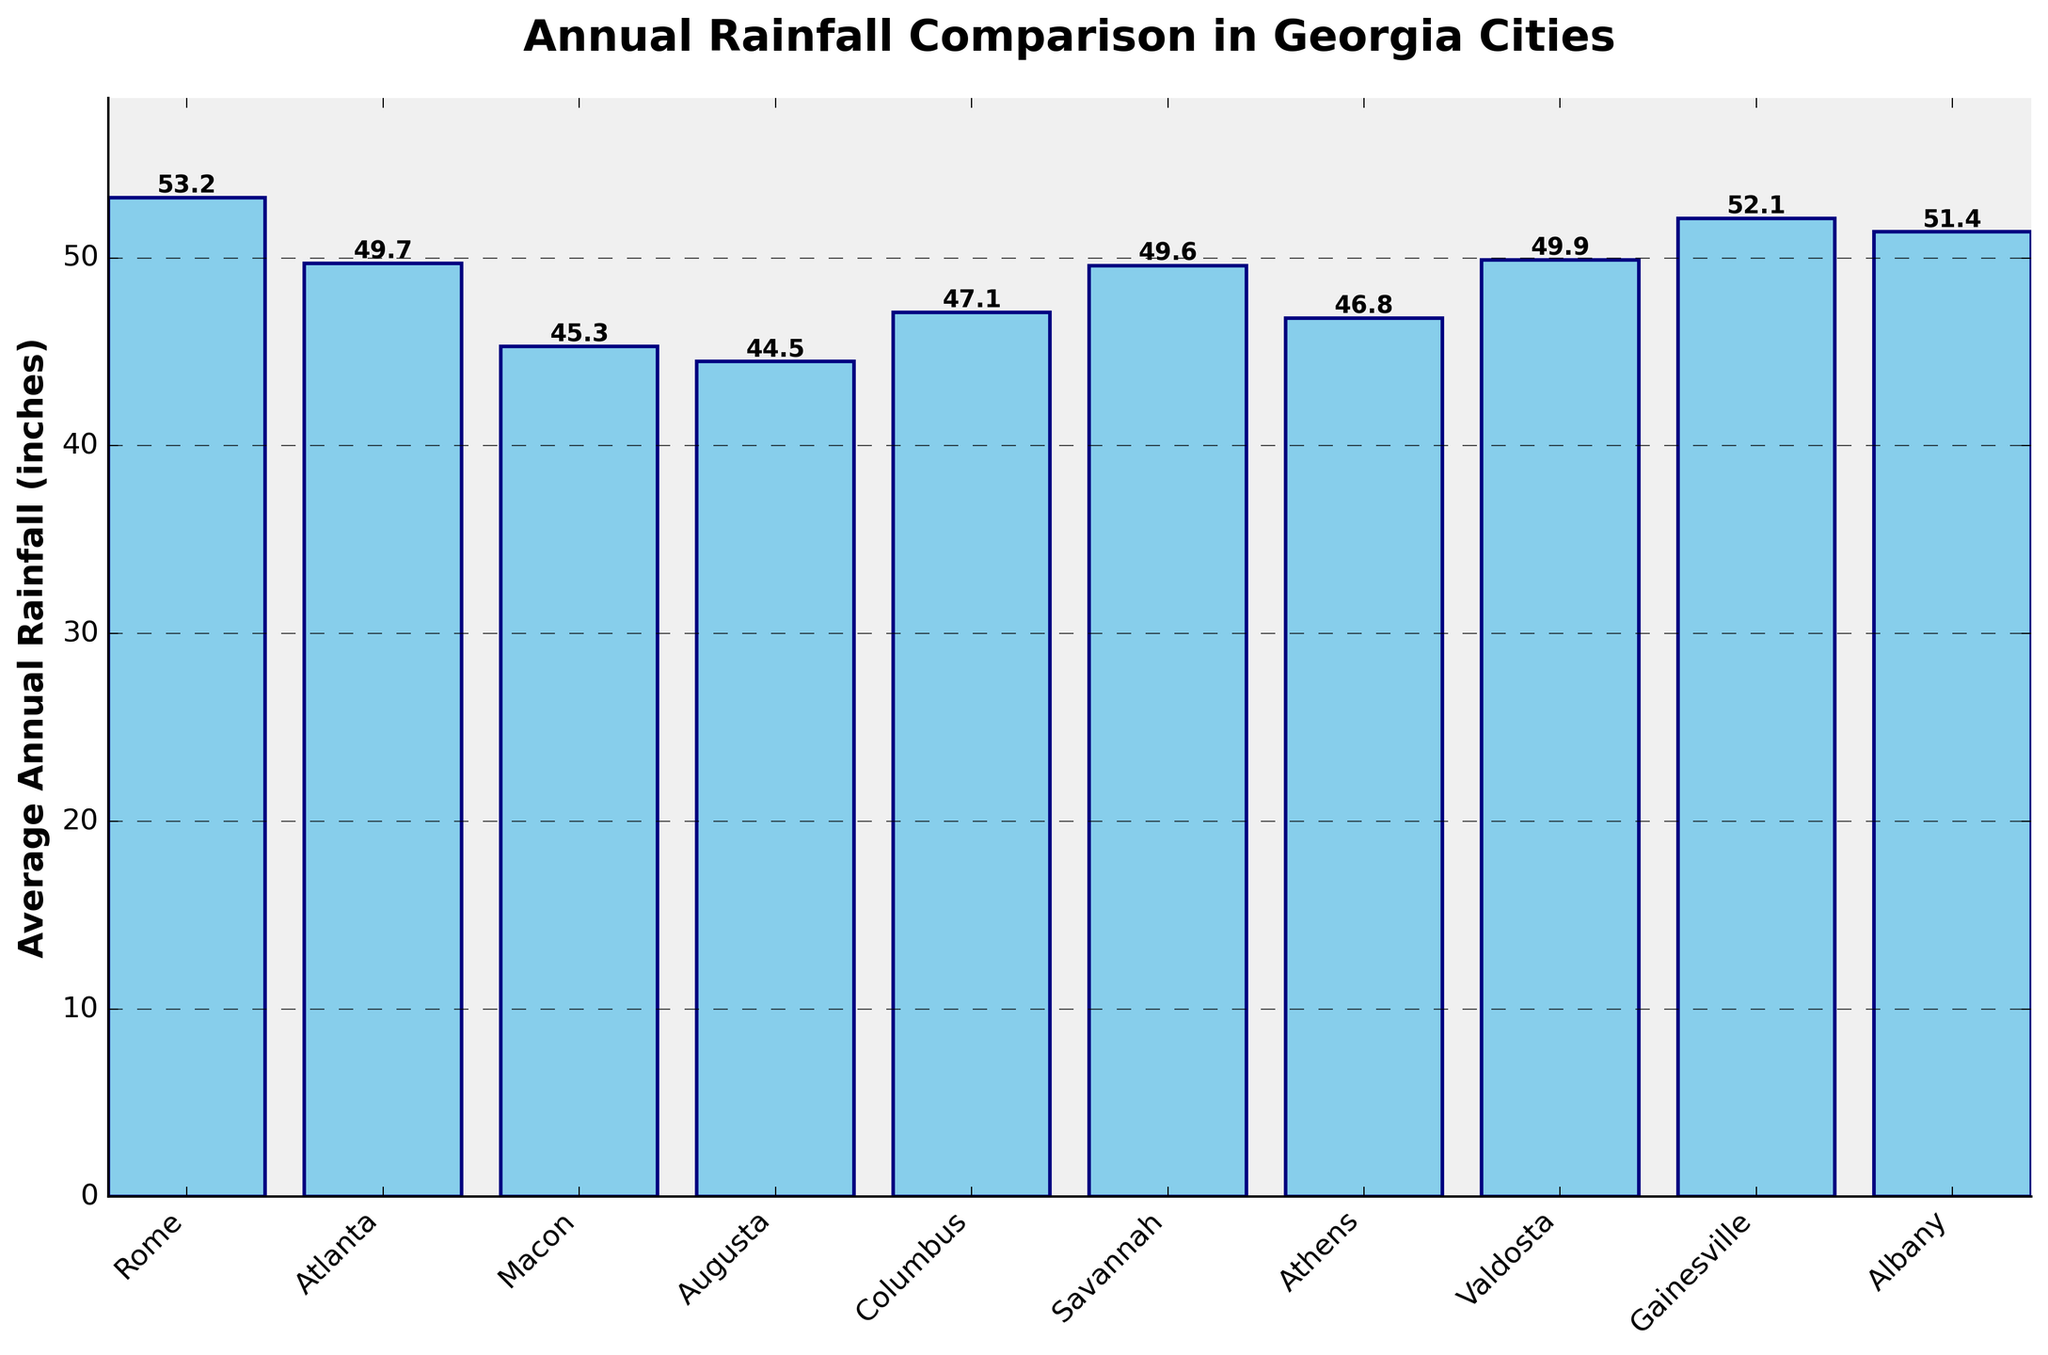What is the average annual rainfall for Rome? The figure shows a bar for each city, with the height representing the average annual rainfall. By looking at the height of Rome’s bar and the value displayed, we can find the average annual rainfall for Rome.
Answer: 53.2 inches Which city has the highest average annual rainfall? To determine the city with the highest average annual rainfall, compare the heights of all the bars to find the tallest one, and note its corresponding city.
Answer: Rome Compare the average annual rainfall of Rome and Atlanta. Which city has more rainfall? Identify the bars representing Rome and Atlanta, and compare their heights (or the values displayed above the bars). Rome’s height of 53.2 inches is greater than Atlanta's 49.7 inches.
Answer: Rome How much more annual rainfall does Rome receive compared to Augusta? Subtract the average annual rainfall of Augusta (44.5 inches) from the average annual rainfall of Rome (53.2 inches) to find the difference.
Answer: 8.7 inches Which city has the least annual rainfall, and how much is it? Look for the shortest bar in the chart and note both the city it represents and the numeric value indicated for that bar.
Answer: Augusta, 44.5 inches What is the average annual rainfall across all the cities represented? Sum up the average annual rainfall values of all cities, then divide by the number of cities. The calculation is (53.2 + 49.7 + 45.3 + 44.5 + 47.1 + 49.6 + 46.8 + 49.9 + 52.1 + 51.4) / 10.
Answer: 48.96 inches How does the average annual rainfall in Savannah compare to that in Columbus? Compare the heights of the Savannah and Columbus bars (or the values displayed above them). Savannah has an average of 49.6 inches, while Columbus has 47.1 inches.
Answer: Savannah has more rain True or False: Rome receives over 50 inches of rain annually. Check the height and value of the bar representing Rome's average annual rainfall. Since it is 53.2 inches, Rome receives over 50 inches.
Answer: True If you combine the average annual rainfall of Albany and Gainesville, how much do they total? Add the average annual rainfall of Albany (51.4 inches) to that of Gainesville (52.1 inches).
Answer: 103.5 inches Identify the city with a bar colored 'skyblue' and a value around 47 inches other than Columbus. Look for the city bars closest to 47 inches and validate their colors as 'skyblue'. Athens has 46.8 inches, which is closest to 47 inches apart from Columbus.
Answer: Athens 